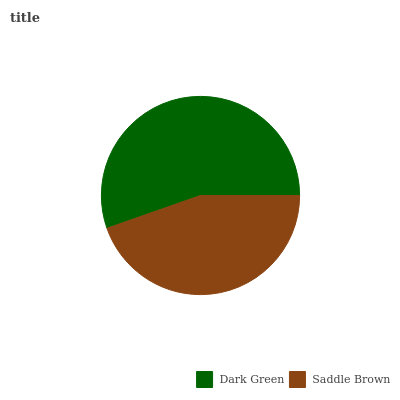Is Saddle Brown the minimum?
Answer yes or no. Yes. Is Dark Green the maximum?
Answer yes or no. Yes. Is Saddle Brown the maximum?
Answer yes or no. No. Is Dark Green greater than Saddle Brown?
Answer yes or no. Yes. Is Saddle Brown less than Dark Green?
Answer yes or no. Yes. Is Saddle Brown greater than Dark Green?
Answer yes or no. No. Is Dark Green less than Saddle Brown?
Answer yes or no. No. Is Dark Green the high median?
Answer yes or no. Yes. Is Saddle Brown the low median?
Answer yes or no. Yes. Is Saddle Brown the high median?
Answer yes or no. No. Is Dark Green the low median?
Answer yes or no. No. 